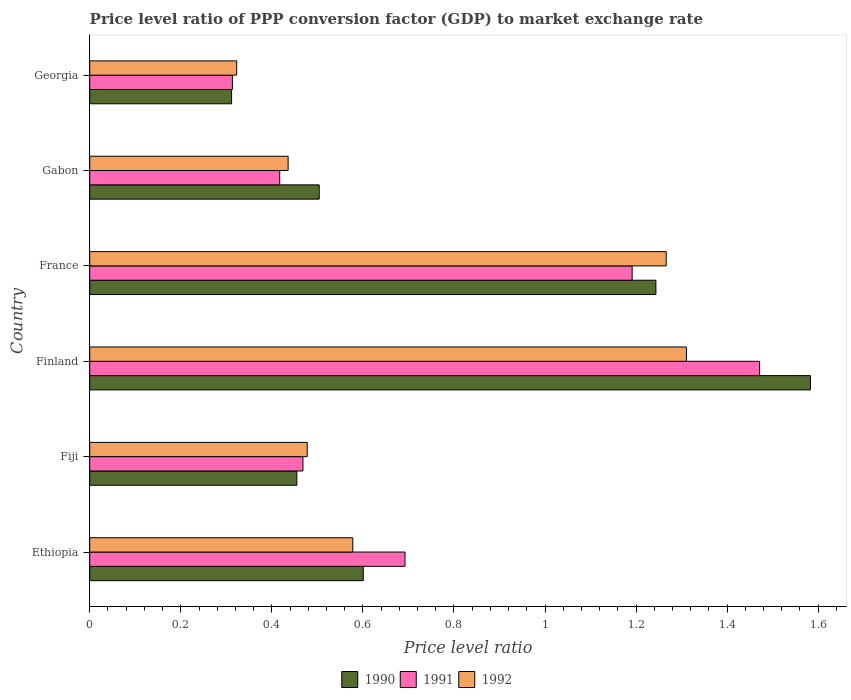How many groups of bars are there?
Ensure brevity in your answer.  6. Are the number of bars per tick equal to the number of legend labels?
Your response must be concise. Yes. Are the number of bars on each tick of the Y-axis equal?
Offer a very short reply. Yes. How many bars are there on the 3rd tick from the top?
Ensure brevity in your answer.  3. How many bars are there on the 5th tick from the bottom?
Your response must be concise. 3. What is the label of the 3rd group of bars from the top?
Your answer should be very brief. France. In how many cases, is the number of bars for a given country not equal to the number of legend labels?
Provide a succinct answer. 0. What is the price level ratio in 1991 in Gabon?
Offer a terse response. 0.42. Across all countries, what is the maximum price level ratio in 1991?
Keep it short and to the point. 1.47. Across all countries, what is the minimum price level ratio in 1991?
Ensure brevity in your answer.  0.31. In which country was the price level ratio in 1990 minimum?
Give a very brief answer. Georgia. What is the total price level ratio in 1992 in the graph?
Your answer should be compact. 4.39. What is the difference between the price level ratio in 1990 in Ethiopia and that in Gabon?
Provide a short and direct response. 0.1. What is the difference between the price level ratio in 1992 in Ethiopia and the price level ratio in 1990 in Finland?
Your answer should be compact. -1.01. What is the average price level ratio in 1990 per country?
Give a very brief answer. 0.78. What is the difference between the price level ratio in 1991 and price level ratio in 1992 in France?
Your answer should be compact. -0.07. In how many countries, is the price level ratio in 1991 greater than 0.48000000000000004 ?
Offer a very short reply. 3. What is the ratio of the price level ratio in 1992 in Finland to that in France?
Provide a short and direct response. 1.04. Is the price level ratio in 1992 in Fiji less than that in Gabon?
Provide a short and direct response. No. What is the difference between the highest and the second highest price level ratio in 1991?
Provide a short and direct response. 0.28. What is the difference between the highest and the lowest price level ratio in 1992?
Offer a very short reply. 0.99. In how many countries, is the price level ratio in 1992 greater than the average price level ratio in 1992 taken over all countries?
Your answer should be very brief. 2. What does the 1st bar from the top in Ethiopia represents?
Keep it short and to the point. 1992. How many bars are there?
Ensure brevity in your answer.  18. How many countries are there in the graph?
Your answer should be compact. 6. Are the values on the major ticks of X-axis written in scientific E-notation?
Provide a succinct answer. No. Does the graph contain grids?
Make the answer very short. No. How many legend labels are there?
Make the answer very short. 3. What is the title of the graph?
Offer a very short reply. Price level ratio of PPP conversion factor (GDP) to market exchange rate. What is the label or title of the X-axis?
Your answer should be compact. Price level ratio. What is the label or title of the Y-axis?
Give a very brief answer. Country. What is the Price level ratio in 1990 in Ethiopia?
Your response must be concise. 0.6. What is the Price level ratio of 1991 in Ethiopia?
Your answer should be very brief. 0.69. What is the Price level ratio of 1992 in Ethiopia?
Provide a short and direct response. 0.58. What is the Price level ratio in 1990 in Fiji?
Make the answer very short. 0.45. What is the Price level ratio in 1991 in Fiji?
Give a very brief answer. 0.47. What is the Price level ratio in 1992 in Fiji?
Your response must be concise. 0.48. What is the Price level ratio of 1990 in Finland?
Ensure brevity in your answer.  1.58. What is the Price level ratio of 1991 in Finland?
Provide a short and direct response. 1.47. What is the Price level ratio in 1992 in Finland?
Your response must be concise. 1.31. What is the Price level ratio in 1990 in France?
Your response must be concise. 1.24. What is the Price level ratio in 1991 in France?
Offer a terse response. 1.19. What is the Price level ratio in 1992 in France?
Your answer should be compact. 1.27. What is the Price level ratio of 1990 in Gabon?
Give a very brief answer. 0.5. What is the Price level ratio of 1991 in Gabon?
Give a very brief answer. 0.42. What is the Price level ratio of 1992 in Gabon?
Your response must be concise. 0.44. What is the Price level ratio of 1990 in Georgia?
Ensure brevity in your answer.  0.31. What is the Price level ratio in 1991 in Georgia?
Ensure brevity in your answer.  0.31. What is the Price level ratio of 1992 in Georgia?
Keep it short and to the point. 0.32. Across all countries, what is the maximum Price level ratio of 1990?
Your answer should be very brief. 1.58. Across all countries, what is the maximum Price level ratio of 1991?
Ensure brevity in your answer.  1.47. Across all countries, what is the maximum Price level ratio in 1992?
Offer a very short reply. 1.31. Across all countries, what is the minimum Price level ratio in 1990?
Your answer should be very brief. 0.31. Across all countries, what is the minimum Price level ratio in 1991?
Offer a very short reply. 0.31. Across all countries, what is the minimum Price level ratio of 1992?
Give a very brief answer. 0.32. What is the total Price level ratio of 1990 in the graph?
Keep it short and to the point. 4.7. What is the total Price level ratio of 1991 in the graph?
Provide a succinct answer. 4.55. What is the total Price level ratio in 1992 in the graph?
Keep it short and to the point. 4.39. What is the difference between the Price level ratio of 1990 in Ethiopia and that in Fiji?
Offer a very short reply. 0.15. What is the difference between the Price level ratio of 1991 in Ethiopia and that in Fiji?
Offer a very short reply. 0.22. What is the difference between the Price level ratio of 1992 in Ethiopia and that in Fiji?
Your response must be concise. 0.1. What is the difference between the Price level ratio of 1990 in Ethiopia and that in Finland?
Provide a short and direct response. -0.98. What is the difference between the Price level ratio of 1991 in Ethiopia and that in Finland?
Offer a very short reply. -0.78. What is the difference between the Price level ratio in 1992 in Ethiopia and that in Finland?
Provide a succinct answer. -0.73. What is the difference between the Price level ratio of 1990 in Ethiopia and that in France?
Provide a succinct answer. -0.64. What is the difference between the Price level ratio of 1991 in Ethiopia and that in France?
Make the answer very short. -0.5. What is the difference between the Price level ratio of 1992 in Ethiopia and that in France?
Your answer should be compact. -0.69. What is the difference between the Price level ratio in 1990 in Ethiopia and that in Gabon?
Provide a succinct answer. 0.1. What is the difference between the Price level ratio in 1991 in Ethiopia and that in Gabon?
Offer a terse response. 0.28. What is the difference between the Price level ratio of 1992 in Ethiopia and that in Gabon?
Provide a succinct answer. 0.14. What is the difference between the Price level ratio of 1990 in Ethiopia and that in Georgia?
Ensure brevity in your answer.  0.29. What is the difference between the Price level ratio of 1991 in Ethiopia and that in Georgia?
Make the answer very short. 0.38. What is the difference between the Price level ratio in 1992 in Ethiopia and that in Georgia?
Ensure brevity in your answer.  0.26. What is the difference between the Price level ratio of 1990 in Fiji and that in Finland?
Provide a succinct answer. -1.13. What is the difference between the Price level ratio in 1991 in Fiji and that in Finland?
Keep it short and to the point. -1. What is the difference between the Price level ratio of 1992 in Fiji and that in Finland?
Offer a terse response. -0.83. What is the difference between the Price level ratio in 1990 in Fiji and that in France?
Your response must be concise. -0.79. What is the difference between the Price level ratio of 1991 in Fiji and that in France?
Your response must be concise. -0.72. What is the difference between the Price level ratio of 1992 in Fiji and that in France?
Your answer should be very brief. -0.79. What is the difference between the Price level ratio of 1990 in Fiji and that in Gabon?
Keep it short and to the point. -0.05. What is the difference between the Price level ratio of 1991 in Fiji and that in Gabon?
Provide a short and direct response. 0.05. What is the difference between the Price level ratio in 1992 in Fiji and that in Gabon?
Make the answer very short. 0.04. What is the difference between the Price level ratio of 1990 in Fiji and that in Georgia?
Your answer should be compact. 0.14. What is the difference between the Price level ratio of 1991 in Fiji and that in Georgia?
Your answer should be compact. 0.15. What is the difference between the Price level ratio of 1992 in Fiji and that in Georgia?
Your answer should be compact. 0.15. What is the difference between the Price level ratio of 1990 in Finland and that in France?
Your answer should be very brief. 0.34. What is the difference between the Price level ratio of 1991 in Finland and that in France?
Your answer should be very brief. 0.28. What is the difference between the Price level ratio in 1992 in Finland and that in France?
Offer a terse response. 0.04. What is the difference between the Price level ratio in 1990 in Finland and that in Gabon?
Offer a terse response. 1.08. What is the difference between the Price level ratio of 1991 in Finland and that in Gabon?
Your answer should be compact. 1.05. What is the difference between the Price level ratio in 1992 in Finland and that in Gabon?
Your answer should be compact. 0.87. What is the difference between the Price level ratio of 1990 in Finland and that in Georgia?
Your answer should be compact. 1.27. What is the difference between the Price level ratio in 1991 in Finland and that in Georgia?
Offer a very short reply. 1.16. What is the difference between the Price level ratio in 1992 in Finland and that in Georgia?
Ensure brevity in your answer.  0.99. What is the difference between the Price level ratio of 1990 in France and that in Gabon?
Make the answer very short. 0.74. What is the difference between the Price level ratio of 1991 in France and that in Gabon?
Provide a succinct answer. 0.77. What is the difference between the Price level ratio of 1992 in France and that in Gabon?
Your response must be concise. 0.83. What is the difference between the Price level ratio of 1990 in France and that in Georgia?
Keep it short and to the point. 0.93. What is the difference between the Price level ratio of 1991 in France and that in Georgia?
Make the answer very short. 0.88. What is the difference between the Price level ratio in 1992 in France and that in Georgia?
Your response must be concise. 0.94. What is the difference between the Price level ratio of 1990 in Gabon and that in Georgia?
Provide a short and direct response. 0.19. What is the difference between the Price level ratio in 1991 in Gabon and that in Georgia?
Ensure brevity in your answer.  0.1. What is the difference between the Price level ratio of 1992 in Gabon and that in Georgia?
Offer a very short reply. 0.11. What is the difference between the Price level ratio in 1990 in Ethiopia and the Price level ratio in 1991 in Fiji?
Offer a terse response. 0.13. What is the difference between the Price level ratio in 1990 in Ethiopia and the Price level ratio in 1992 in Fiji?
Provide a succinct answer. 0.12. What is the difference between the Price level ratio in 1991 in Ethiopia and the Price level ratio in 1992 in Fiji?
Offer a very short reply. 0.21. What is the difference between the Price level ratio of 1990 in Ethiopia and the Price level ratio of 1991 in Finland?
Your answer should be very brief. -0.87. What is the difference between the Price level ratio in 1990 in Ethiopia and the Price level ratio in 1992 in Finland?
Make the answer very short. -0.71. What is the difference between the Price level ratio of 1991 in Ethiopia and the Price level ratio of 1992 in Finland?
Provide a short and direct response. -0.62. What is the difference between the Price level ratio of 1990 in Ethiopia and the Price level ratio of 1991 in France?
Offer a terse response. -0.59. What is the difference between the Price level ratio of 1990 in Ethiopia and the Price level ratio of 1992 in France?
Ensure brevity in your answer.  -0.67. What is the difference between the Price level ratio of 1991 in Ethiopia and the Price level ratio of 1992 in France?
Give a very brief answer. -0.57. What is the difference between the Price level ratio in 1990 in Ethiopia and the Price level ratio in 1991 in Gabon?
Provide a short and direct response. 0.18. What is the difference between the Price level ratio of 1990 in Ethiopia and the Price level ratio of 1992 in Gabon?
Ensure brevity in your answer.  0.17. What is the difference between the Price level ratio of 1991 in Ethiopia and the Price level ratio of 1992 in Gabon?
Give a very brief answer. 0.26. What is the difference between the Price level ratio in 1990 in Ethiopia and the Price level ratio in 1991 in Georgia?
Offer a terse response. 0.29. What is the difference between the Price level ratio of 1990 in Ethiopia and the Price level ratio of 1992 in Georgia?
Your response must be concise. 0.28. What is the difference between the Price level ratio in 1991 in Ethiopia and the Price level ratio in 1992 in Georgia?
Your response must be concise. 0.37. What is the difference between the Price level ratio of 1990 in Fiji and the Price level ratio of 1991 in Finland?
Your response must be concise. -1.02. What is the difference between the Price level ratio of 1990 in Fiji and the Price level ratio of 1992 in Finland?
Ensure brevity in your answer.  -0.86. What is the difference between the Price level ratio of 1991 in Fiji and the Price level ratio of 1992 in Finland?
Provide a short and direct response. -0.84. What is the difference between the Price level ratio of 1990 in Fiji and the Price level ratio of 1991 in France?
Provide a succinct answer. -0.74. What is the difference between the Price level ratio of 1990 in Fiji and the Price level ratio of 1992 in France?
Provide a short and direct response. -0.81. What is the difference between the Price level ratio of 1991 in Fiji and the Price level ratio of 1992 in France?
Ensure brevity in your answer.  -0.8. What is the difference between the Price level ratio of 1990 in Fiji and the Price level ratio of 1991 in Gabon?
Keep it short and to the point. 0.04. What is the difference between the Price level ratio of 1990 in Fiji and the Price level ratio of 1992 in Gabon?
Your response must be concise. 0.02. What is the difference between the Price level ratio in 1991 in Fiji and the Price level ratio in 1992 in Gabon?
Your answer should be very brief. 0.03. What is the difference between the Price level ratio in 1990 in Fiji and the Price level ratio in 1991 in Georgia?
Your answer should be very brief. 0.14. What is the difference between the Price level ratio of 1990 in Fiji and the Price level ratio of 1992 in Georgia?
Ensure brevity in your answer.  0.13. What is the difference between the Price level ratio in 1991 in Fiji and the Price level ratio in 1992 in Georgia?
Your answer should be compact. 0.15. What is the difference between the Price level ratio in 1990 in Finland and the Price level ratio in 1991 in France?
Make the answer very short. 0.39. What is the difference between the Price level ratio of 1990 in Finland and the Price level ratio of 1992 in France?
Offer a terse response. 0.32. What is the difference between the Price level ratio in 1991 in Finland and the Price level ratio in 1992 in France?
Ensure brevity in your answer.  0.21. What is the difference between the Price level ratio of 1990 in Finland and the Price level ratio of 1991 in Gabon?
Give a very brief answer. 1.17. What is the difference between the Price level ratio of 1990 in Finland and the Price level ratio of 1992 in Gabon?
Your response must be concise. 1.15. What is the difference between the Price level ratio of 1991 in Finland and the Price level ratio of 1992 in Gabon?
Make the answer very short. 1.04. What is the difference between the Price level ratio in 1990 in Finland and the Price level ratio in 1991 in Georgia?
Offer a very short reply. 1.27. What is the difference between the Price level ratio in 1990 in Finland and the Price level ratio in 1992 in Georgia?
Your response must be concise. 1.26. What is the difference between the Price level ratio of 1991 in Finland and the Price level ratio of 1992 in Georgia?
Give a very brief answer. 1.15. What is the difference between the Price level ratio in 1990 in France and the Price level ratio in 1991 in Gabon?
Offer a very short reply. 0.83. What is the difference between the Price level ratio in 1990 in France and the Price level ratio in 1992 in Gabon?
Give a very brief answer. 0.81. What is the difference between the Price level ratio in 1991 in France and the Price level ratio in 1992 in Gabon?
Provide a short and direct response. 0.76. What is the difference between the Price level ratio in 1990 in France and the Price level ratio in 1991 in Georgia?
Offer a terse response. 0.93. What is the difference between the Price level ratio of 1990 in France and the Price level ratio of 1992 in Georgia?
Make the answer very short. 0.92. What is the difference between the Price level ratio of 1991 in France and the Price level ratio of 1992 in Georgia?
Offer a very short reply. 0.87. What is the difference between the Price level ratio in 1990 in Gabon and the Price level ratio in 1991 in Georgia?
Your answer should be very brief. 0.19. What is the difference between the Price level ratio in 1990 in Gabon and the Price level ratio in 1992 in Georgia?
Ensure brevity in your answer.  0.18. What is the difference between the Price level ratio in 1991 in Gabon and the Price level ratio in 1992 in Georgia?
Your response must be concise. 0.09. What is the average Price level ratio in 1990 per country?
Make the answer very short. 0.78. What is the average Price level ratio of 1991 per country?
Provide a short and direct response. 0.76. What is the average Price level ratio in 1992 per country?
Your answer should be compact. 0.73. What is the difference between the Price level ratio of 1990 and Price level ratio of 1991 in Ethiopia?
Offer a terse response. -0.09. What is the difference between the Price level ratio of 1990 and Price level ratio of 1992 in Ethiopia?
Offer a very short reply. 0.02. What is the difference between the Price level ratio of 1991 and Price level ratio of 1992 in Ethiopia?
Your answer should be very brief. 0.11. What is the difference between the Price level ratio in 1990 and Price level ratio in 1991 in Fiji?
Give a very brief answer. -0.01. What is the difference between the Price level ratio in 1990 and Price level ratio in 1992 in Fiji?
Your response must be concise. -0.02. What is the difference between the Price level ratio in 1991 and Price level ratio in 1992 in Fiji?
Your answer should be very brief. -0.01. What is the difference between the Price level ratio of 1990 and Price level ratio of 1991 in Finland?
Make the answer very short. 0.11. What is the difference between the Price level ratio of 1990 and Price level ratio of 1992 in Finland?
Make the answer very short. 0.27. What is the difference between the Price level ratio of 1991 and Price level ratio of 1992 in Finland?
Make the answer very short. 0.16. What is the difference between the Price level ratio of 1990 and Price level ratio of 1991 in France?
Give a very brief answer. 0.05. What is the difference between the Price level ratio of 1990 and Price level ratio of 1992 in France?
Keep it short and to the point. -0.02. What is the difference between the Price level ratio of 1991 and Price level ratio of 1992 in France?
Ensure brevity in your answer.  -0.07. What is the difference between the Price level ratio of 1990 and Price level ratio of 1991 in Gabon?
Keep it short and to the point. 0.09. What is the difference between the Price level ratio of 1990 and Price level ratio of 1992 in Gabon?
Provide a succinct answer. 0.07. What is the difference between the Price level ratio in 1991 and Price level ratio in 1992 in Gabon?
Offer a terse response. -0.02. What is the difference between the Price level ratio in 1990 and Price level ratio in 1991 in Georgia?
Offer a very short reply. -0. What is the difference between the Price level ratio in 1990 and Price level ratio in 1992 in Georgia?
Offer a terse response. -0.01. What is the difference between the Price level ratio of 1991 and Price level ratio of 1992 in Georgia?
Your answer should be compact. -0.01. What is the ratio of the Price level ratio of 1990 in Ethiopia to that in Fiji?
Provide a short and direct response. 1.32. What is the ratio of the Price level ratio in 1991 in Ethiopia to that in Fiji?
Your response must be concise. 1.48. What is the ratio of the Price level ratio in 1992 in Ethiopia to that in Fiji?
Keep it short and to the point. 1.21. What is the ratio of the Price level ratio of 1990 in Ethiopia to that in Finland?
Keep it short and to the point. 0.38. What is the ratio of the Price level ratio of 1991 in Ethiopia to that in Finland?
Your answer should be very brief. 0.47. What is the ratio of the Price level ratio of 1992 in Ethiopia to that in Finland?
Your answer should be compact. 0.44. What is the ratio of the Price level ratio in 1990 in Ethiopia to that in France?
Provide a short and direct response. 0.48. What is the ratio of the Price level ratio of 1991 in Ethiopia to that in France?
Keep it short and to the point. 0.58. What is the ratio of the Price level ratio in 1992 in Ethiopia to that in France?
Keep it short and to the point. 0.46. What is the ratio of the Price level ratio in 1990 in Ethiopia to that in Gabon?
Ensure brevity in your answer.  1.19. What is the ratio of the Price level ratio of 1991 in Ethiopia to that in Gabon?
Offer a terse response. 1.66. What is the ratio of the Price level ratio of 1992 in Ethiopia to that in Gabon?
Offer a very short reply. 1.33. What is the ratio of the Price level ratio of 1990 in Ethiopia to that in Georgia?
Make the answer very short. 1.93. What is the ratio of the Price level ratio in 1991 in Ethiopia to that in Georgia?
Provide a short and direct response. 2.21. What is the ratio of the Price level ratio of 1992 in Ethiopia to that in Georgia?
Keep it short and to the point. 1.79. What is the ratio of the Price level ratio in 1990 in Fiji to that in Finland?
Offer a terse response. 0.29. What is the ratio of the Price level ratio of 1991 in Fiji to that in Finland?
Offer a terse response. 0.32. What is the ratio of the Price level ratio in 1992 in Fiji to that in Finland?
Make the answer very short. 0.36. What is the ratio of the Price level ratio of 1990 in Fiji to that in France?
Your answer should be very brief. 0.37. What is the ratio of the Price level ratio in 1991 in Fiji to that in France?
Give a very brief answer. 0.39. What is the ratio of the Price level ratio in 1992 in Fiji to that in France?
Offer a terse response. 0.38. What is the ratio of the Price level ratio in 1990 in Fiji to that in Gabon?
Provide a succinct answer. 0.9. What is the ratio of the Price level ratio in 1991 in Fiji to that in Gabon?
Provide a short and direct response. 1.12. What is the ratio of the Price level ratio of 1992 in Fiji to that in Gabon?
Your answer should be very brief. 1.1. What is the ratio of the Price level ratio in 1990 in Fiji to that in Georgia?
Give a very brief answer. 1.46. What is the ratio of the Price level ratio in 1991 in Fiji to that in Georgia?
Provide a succinct answer. 1.49. What is the ratio of the Price level ratio of 1992 in Fiji to that in Georgia?
Your answer should be very brief. 1.48. What is the ratio of the Price level ratio in 1990 in Finland to that in France?
Your response must be concise. 1.27. What is the ratio of the Price level ratio of 1991 in Finland to that in France?
Your response must be concise. 1.23. What is the ratio of the Price level ratio in 1992 in Finland to that in France?
Ensure brevity in your answer.  1.04. What is the ratio of the Price level ratio in 1990 in Finland to that in Gabon?
Provide a succinct answer. 3.14. What is the ratio of the Price level ratio of 1991 in Finland to that in Gabon?
Your answer should be compact. 3.53. What is the ratio of the Price level ratio of 1992 in Finland to that in Gabon?
Give a very brief answer. 3.01. What is the ratio of the Price level ratio in 1990 in Finland to that in Georgia?
Offer a very short reply. 5.08. What is the ratio of the Price level ratio of 1991 in Finland to that in Georgia?
Give a very brief answer. 4.7. What is the ratio of the Price level ratio of 1992 in Finland to that in Georgia?
Keep it short and to the point. 4.06. What is the ratio of the Price level ratio in 1990 in France to that in Gabon?
Your answer should be compact. 2.47. What is the ratio of the Price level ratio in 1991 in France to that in Gabon?
Your response must be concise. 2.85. What is the ratio of the Price level ratio in 1992 in France to that in Gabon?
Your answer should be very brief. 2.91. What is the ratio of the Price level ratio of 1990 in France to that in Georgia?
Your response must be concise. 3.99. What is the ratio of the Price level ratio of 1991 in France to that in Georgia?
Your answer should be compact. 3.8. What is the ratio of the Price level ratio in 1992 in France to that in Georgia?
Make the answer very short. 3.92. What is the ratio of the Price level ratio of 1990 in Gabon to that in Georgia?
Give a very brief answer. 1.62. What is the ratio of the Price level ratio of 1991 in Gabon to that in Georgia?
Offer a terse response. 1.33. What is the ratio of the Price level ratio in 1992 in Gabon to that in Georgia?
Your answer should be compact. 1.35. What is the difference between the highest and the second highest Price level ratio of 1990?
Offer a terse response. 0.34. What is the difference between the highest and the second highest Price level ratio of 1991?
Your answer should be very brief. 0.28. What is the difference between the highest and the second highest Price level ratio of 1992?
Provide a short and direct response. 0.04. What is the difference between the highest and the lowest Price level ratio of 1990?
Keep it short and to the point. 1.27. What is the difference between the highest and the lowest Price level ratio in 1991?
Give a very brief answer. 1.16. What is the difference between the highest and the lowest Price level ratio of 1992?
Your answer should be compact. 0.99. 